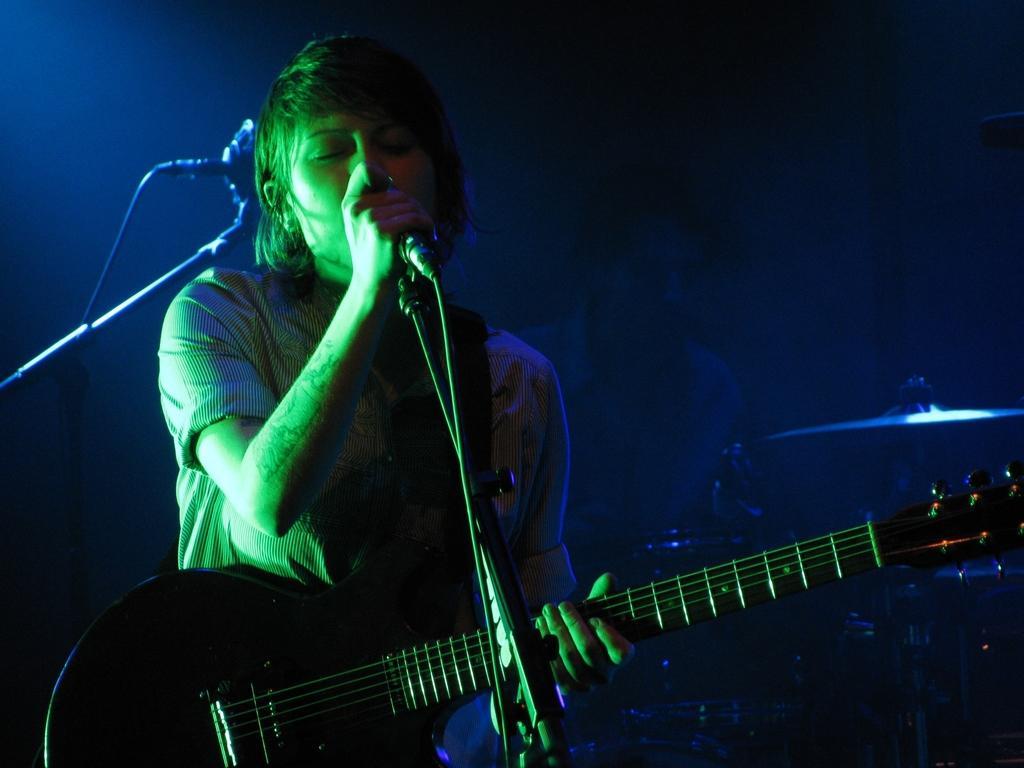Can you describe this image briefly? In this image a lady is singing she is holding a mic she is playing guitar. Behind her one person is playing drums. In the left there is another mic. 